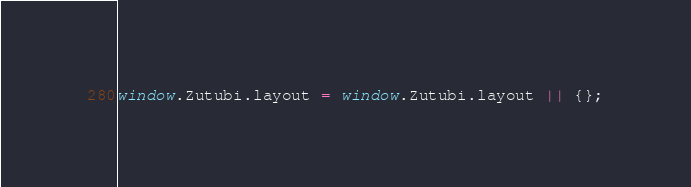<code> <loc_0><loc_0><loc_500><loc_500><_JavaScript_>window.Zutubi.layout = window.Zutubi.layout || {};
</code> 